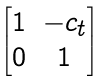Convert formula to latex. <formula><loc_0><loc_0><loc_500><loc_500>\begin{bmatrix} 1 & - c _ { t } \\ 0 & 1 \end{bmatrix}</formula> 